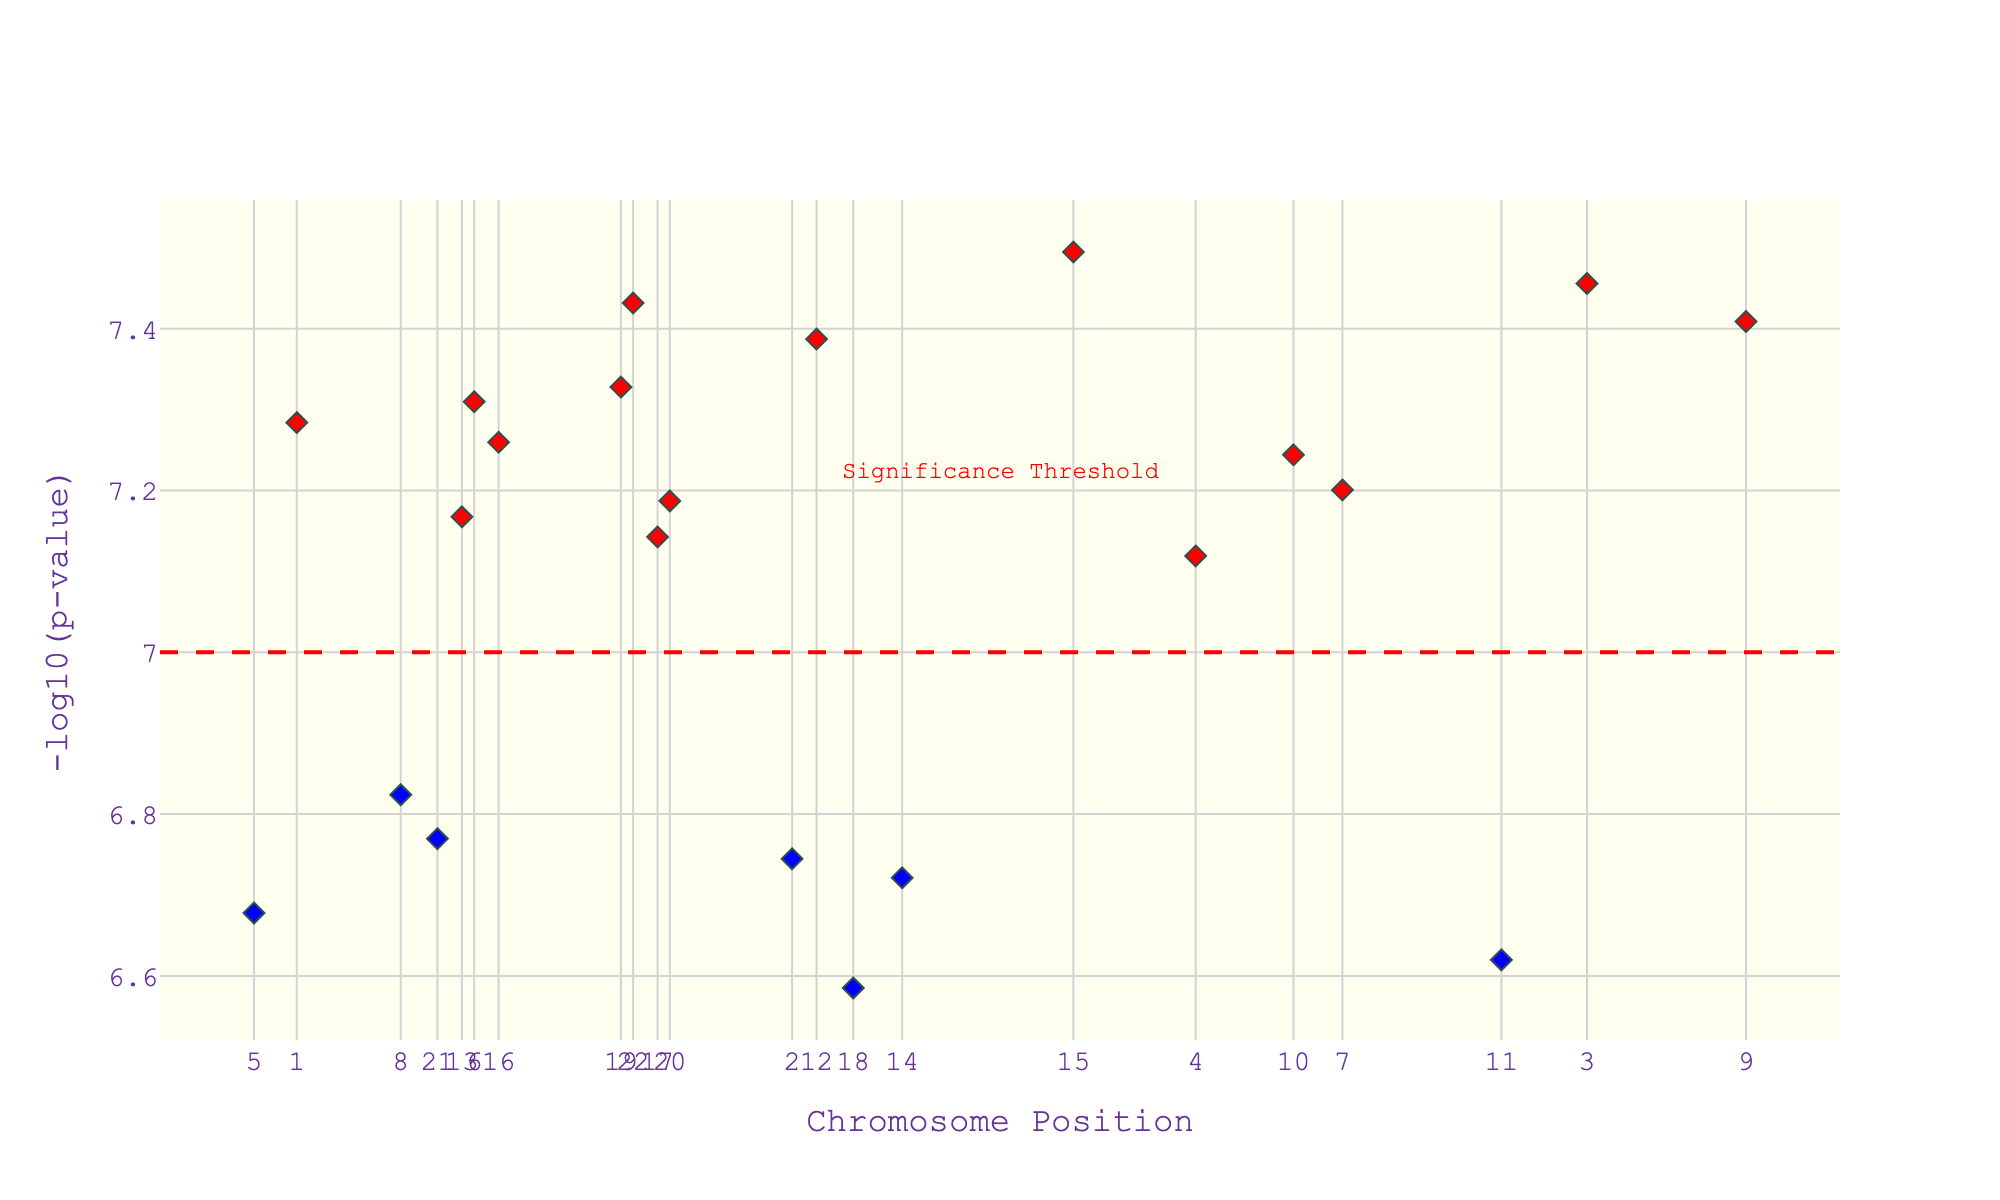What is the title of the plot? The title of the plot is located at the top of the figure. It reads "Manhattan Plot: Genetic Variants Linked to Cinematic Preferences".
Answer: Manhattan Plot: Genetic Variants Linked to Cinematic Preferences What does the y-axis represent? The y-axis represents the values of -log10(p-value), which is a transformation of the p-values from the genetic study. Higher values indicate stronger statistical significance.
Answer: -log10(p-value) How many data points are colored in red? By visually inspecting the plot, we can count the number of red diamond markers, which represent significant data points above the threshold line. There are 11 red markers.
Answer: 11 Which gene is linked to the highest -log10(p-value)? By observing the plot, we look for the highest point on the y-axis and check the hover information that appears, indicating the gene name. The gene with the highest -log10(p-value) is FOXP2.
Answer: FOXP2 What is the significance threshold value in the plot? The significance threshold is indicated by the horizontal dashed red line. The annotation above the line states that this threshold value is 7 on the -log10(p-value) scale.
Answer: 7 Which chromosome has the gene associated with the preference for historical dramas? The hover information over diamond markers includes traits. By hovering over the marker associated with "Preference for historical dramas", it indicates that this trait is associated with chromosome 1.
Answer: chromosome 1 Which gene is associated with the enjoyment of suspenseful thrillers? By looking at the hover information tied to the trait "Enjoyment of suspenseful thrillers", it identifies that this trait is linked with the gene DRD2.
Answer: DRD2 Compare the -log10(p-value) for the genes COMT on chromosome 3 and COMT on chromosome 22. Which one has a higher value? By finding the hover information associated with each COMT marker on chromosome 3 and chromosome 22, we compare their -log10(p-values). The gene COMT on chromosome 3 has a value of approximately 7.46, whereas the COMT on chromosome 22 has a value of 7.43. Thus, chromosome 3's COMT has a slightly higher value.
Answer: COMT on chromosome 3 How many chromosomes are present in the plot? The figure includes tick marks on the x-axis, each representing a chromosome. By tallying these labels from 1 to 22, we find that there are 22 chromosomes.
Answer: 22 Which significant gene is associated with the highest position on chromosome 19? By focusing on chromosome 19 and examining the marker's hover information, the significant gene at the highest position (41,000,000) is APOE.
Answer: APOE 